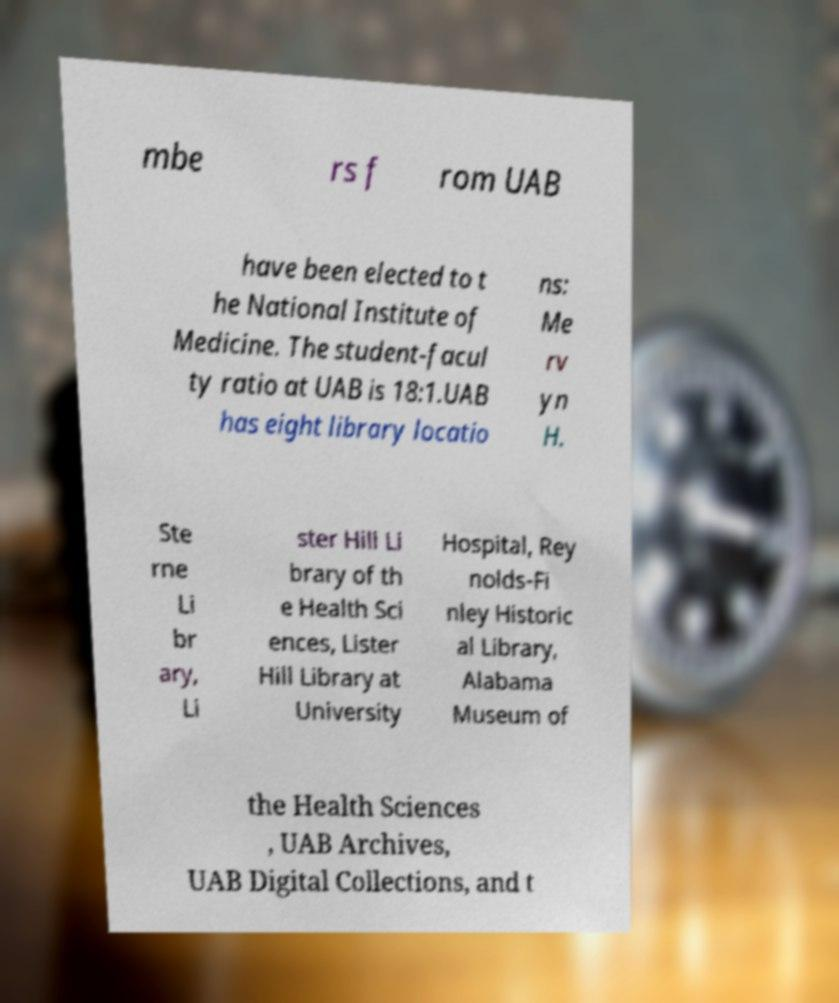Could you extract and type out the text from this image? mbe rs f rom UAB have been elected to t he National Institute of Medicine. The student-facul ty ratio at UAB is 18:1.UAB has eight library locatio ns: Me rv yn H. Ste rne Li br ary, Li ster Hill Li brary of th e Health Sci ences, Lister Hill Library at University Hospital, Rey nolds-Fi nley Historic al Library, Alabama Museum of the Health Sciences , UAB Archives, UAB Digital Collections, and t 